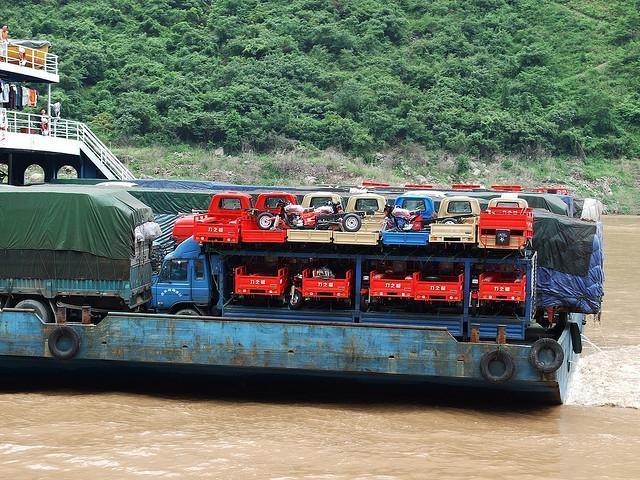How many trucks are there?
Give a very brief answer. 9. 